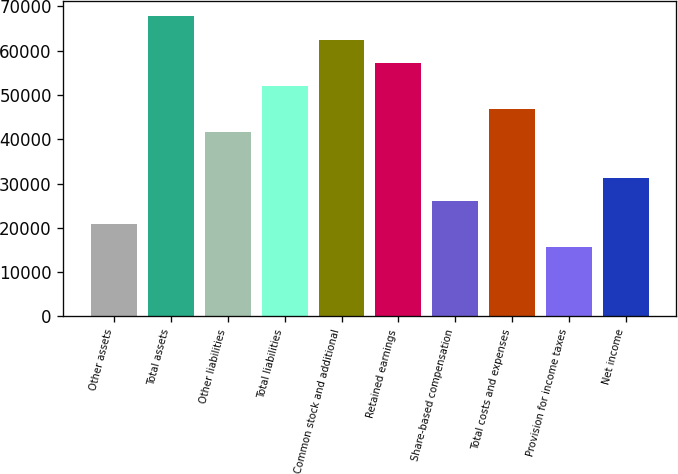Convert chart to OTSL. <chart><loc_0><loc_0><loc_500><loc_500><bar_chart><fcel>Other assets<fcel>Total assets<fcel>Other liabilities<fcel>Total liabilities<fcel>Common stock and additional<fcel>Retained earnings<fcel>Share-based compensation<fcel>Total costs and expenses<fcel>Provision for income taxes<fcel>Net income<nl><fcel>20830.3<fcel>67697.4<fcel>41660.1<fcel>52075<fcel>62489.9<fcel>57282.5<fcel>26037.8<fcel>46867.6<fcel>15622.9<fcel>31245.2<nl></chart> 